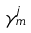Convert formula to latex. <formula><loc_0><loc_0><loc_500><loc_500>\gamma _ { m } ^ { j }</formula> 